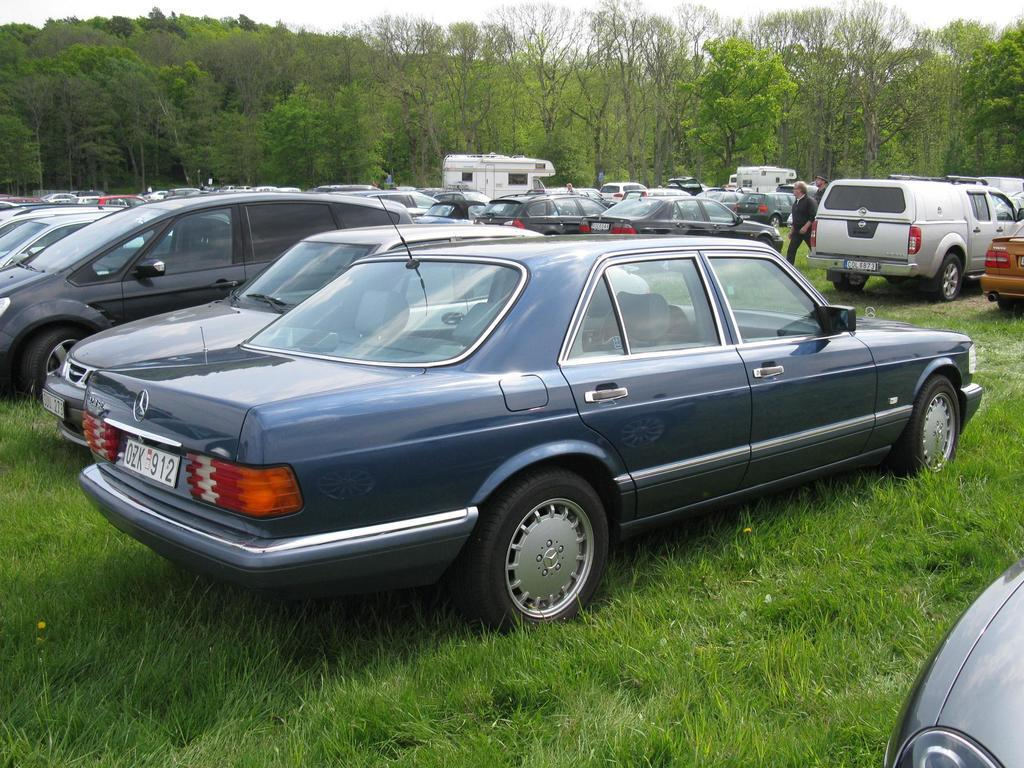<image>
Give a short and clear explanation of the subsequent image. A Mercedes with a tag that reads OZK912. 